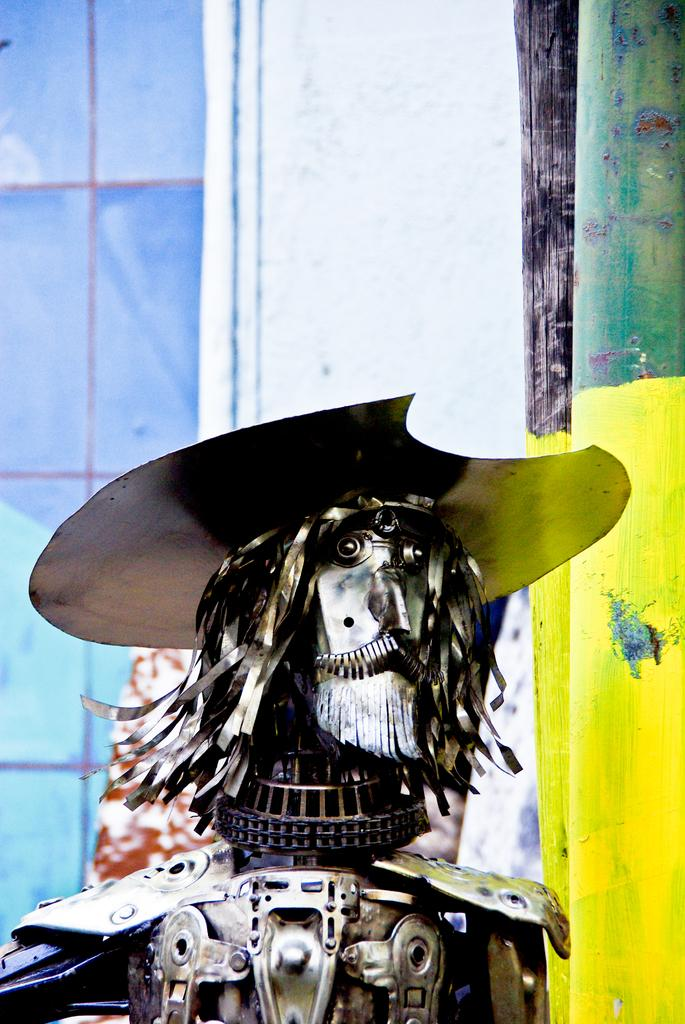What is the main subject in the image? There is a statue in the image. What other object can be seen in the image besides the statue? There is a pole in the image. What is visible in the background of the image? There is a wall in the background of the image. What type of branch can be seen growing out of the statue's stomach in the image? There is no branch growing out of the statue's stomach in the image, as the statue does not have a stomach. 